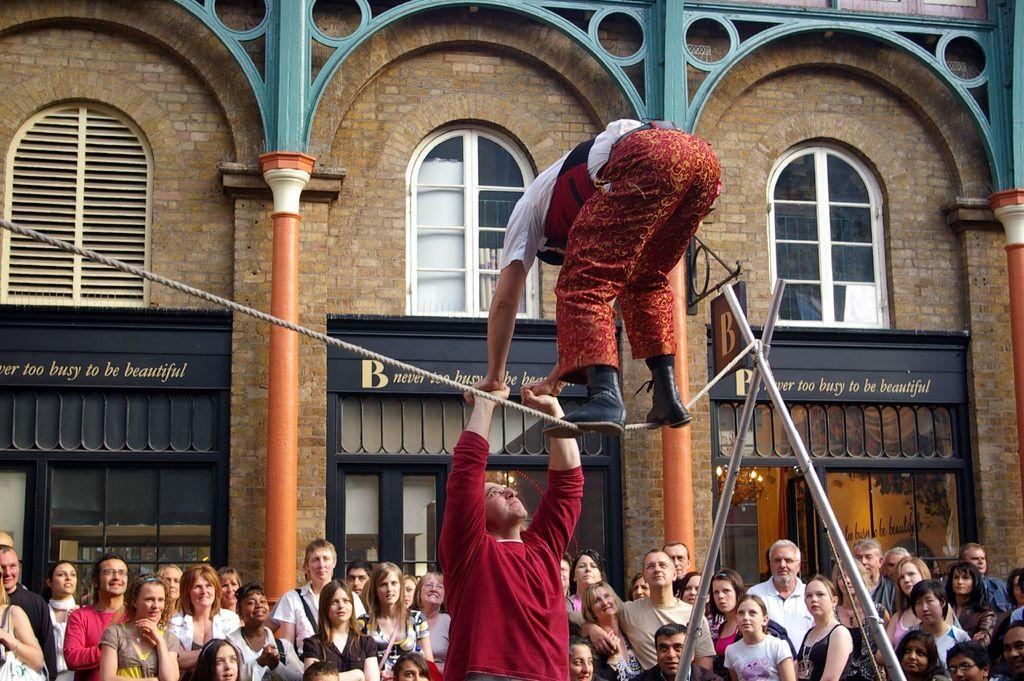Can you describe this image briefly? In the picture I can see a person standing on a rope which is attached to the stand beside him and holding hands of a person standing in front of him and there are few audience and a building in the background. 